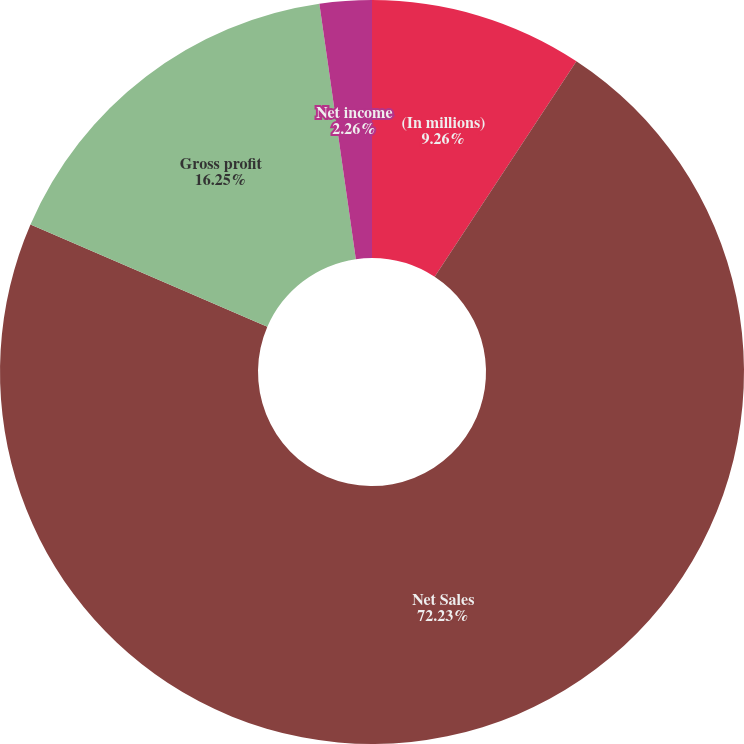Convert chart to OTSL. <chart><loc_0><loc_0><loc_500><loc_500><pie_chart><fcel>(In millions)<fcel>Net Sales<fcel>Gross profit<fcel>Net income<nl><fcel>9.26%<fcel>72.23%<fcel>16.25%<fcel>2.26%<nl></chart> 